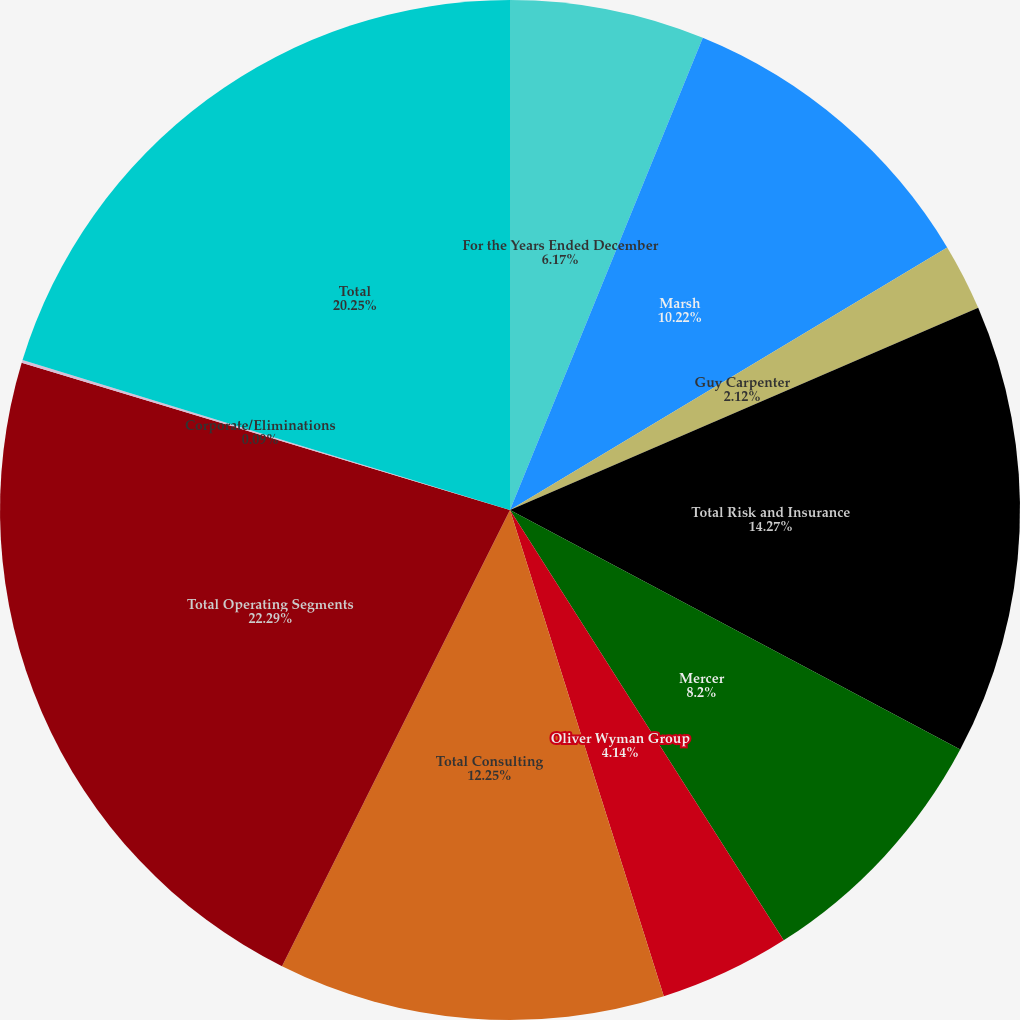<chart> <loc_0><loc_0><loc_500><loc_500><pie_chart><fcel>For the Years Ended December<fcel>Marsh<fcel>Guy Carpenter<fcel>Total Risk and Insurance<fcel>Mercer<fcel>Oliver Wyman Group<fcel>Total Consulting<fcel>Total Operating Segments<fcel>Corporate/Eliminations<fcel>Total<nl><fcel>6.17%<fcel>10.22%<fcel>2.12%<fcel>14.27%<fcel>8.2%<fcel>4.14%<fcel>12.25%<fcel>22.28%<fcel>0.09%<fcel>20.25%<nl></chart> 